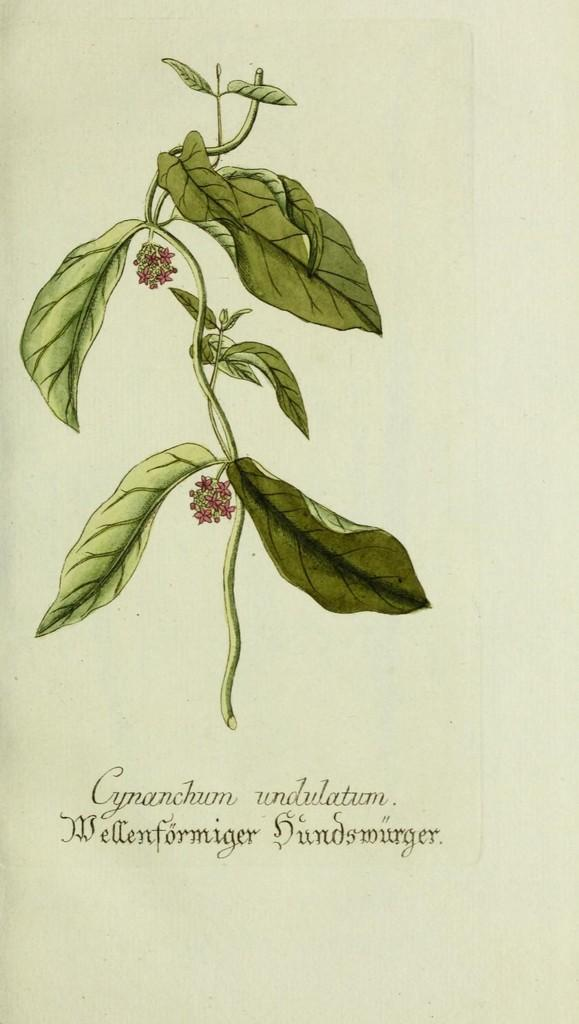What is present on the paper in the image? Something is written on the paper in the image. What else can be seen in the image besides the paper? There is a painting in the image. Can you describe the painting in the image? The painting depicts a stem with leaves and flowers. How many balls are being used in the meal depicted in the image? There are no balls or meals present in the image; it features a paper with writing and a painting of a stem with leaves and flowers. 